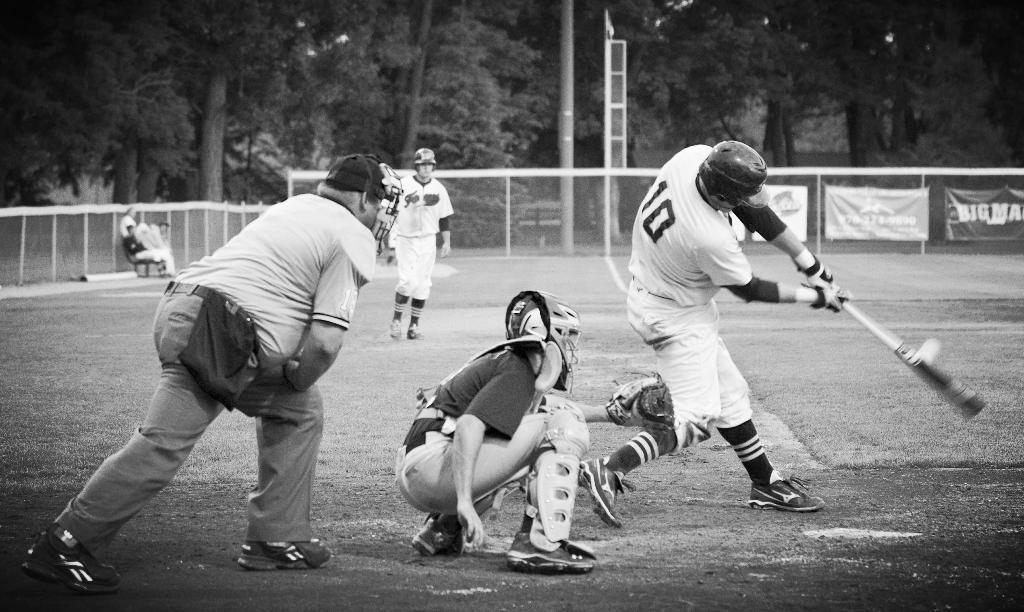What are the people in the image doing? The people are playing cricket in the image. Where is the cricket game taking place? The cricket game is taking place on a ground. What can be seen in the background of the image? There is a fence visible in the image, and behind the fence, there are trees. What type of yarn is being used to create the art in the image? There is no art or yarn present in the image; it features a group of people playing cricket on a ground. 